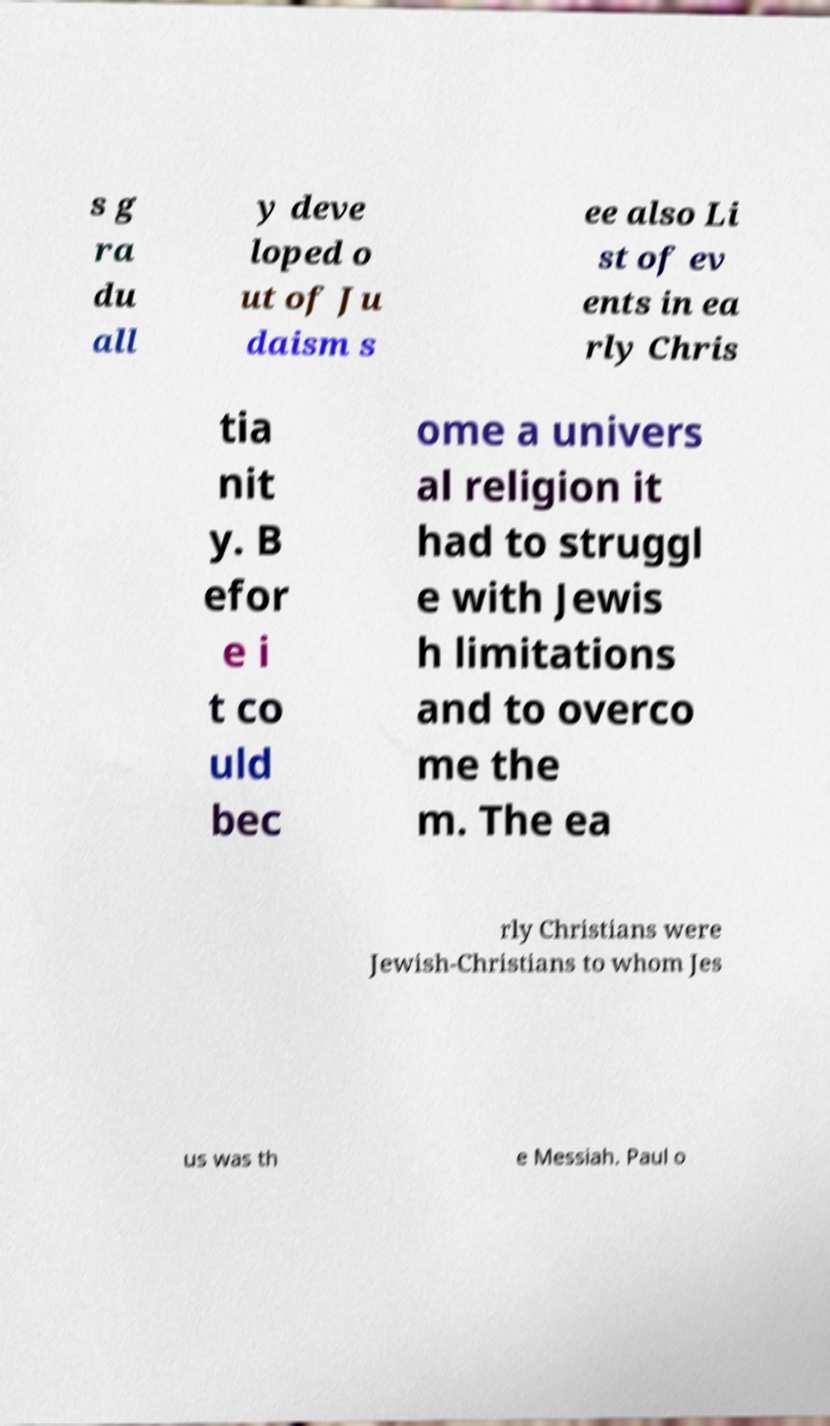For documentation purposes, I need the text within this image transcribed. Could you provide that? s g ra du all y deve loped o ut of Ju daism s ee also Li st of ev ents in ea rly Chris tia nit y. B efor e i t co uld bec ome a univers al religion it had to struggl e with Jewis h limitations and to overco me the m. The ea rly Christians were Jewish-Christians to whom Jes us was th e Messiah. Paul o 